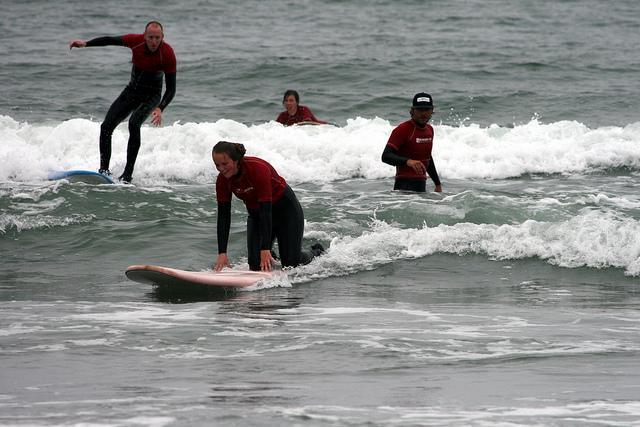What does the girl walking into the water is waiting for what to come from directly behind her so she can stand up on the board from the water waiting for what the only thing that will get her on moving on the board? wave 